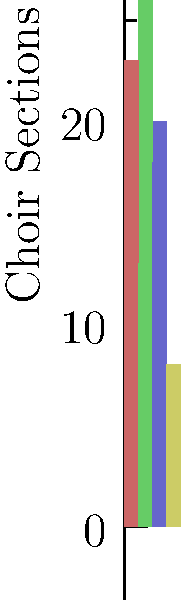As a music industry professional promoting choral compositions, you're analyzing the vocal range distribution of a prestigious choir. The stacked bar chart shows the number of singers in each vocal range (Soprano, Alto, Tenor, Bass) for different choir sections. What strategic insight can you derive about the choir's vocal balance and its potential impact on repertoire selection? To analyze the choir's vocal balance and its impact on repertoire selection, let's break down the information in the stacked bar chart:

1. Examine each choir section:
   a) Section 1 (bottom): Balanced distribution with a slight emphasis on Tenor voices
   b) Section 2: Strong Alto presence, fewer Sopranos and Tenors
   c) Section 3: Balanced between Soprano and Alto, fewer Tenors
   d) Section 4 (top): Dominant Soprano presence

2. Overall choir composition:
   - Sopranos are well-represented across all sections
   - Altos have a strong presence, especially in Section 2
   - Tenors are consistently present but in smaller numbers
   - Bass voices are consistently the smallest group

3. Implications for repertoire selection:
   a) The choir has strength in higher voices (Soprano and Alto), allowing for complex harmonies in upper ranges
   b) The consistent but smaller number of Tenors and Basses suggests care should be taken not to overburden these voices
   c) The choir could excel in pieces that feature strong Soprano lines or Soprano-Alto duets
   d) Works with intricate Bass parts might be challenging due to the smaller Bass section

4. Strategic insights:
   - Promote compositions that showcase the choir's strength in upper voices
   - Look for pieces with interesting Alto parts to utilize the strong Alto section
   - Consider arrangements that distribute the lower-range parts among Tenors and Basses to compensate for the smaller Bass section
   - The choir's diverse vocal distribution allows for a wide range of repertoire, but with careful consideration of balance
Answer: The choir excels in upper voices, allowing for complex soprano-alto harmonies, but requires careful selection of pieces to accommodate the smaller tenor and bass sections. 